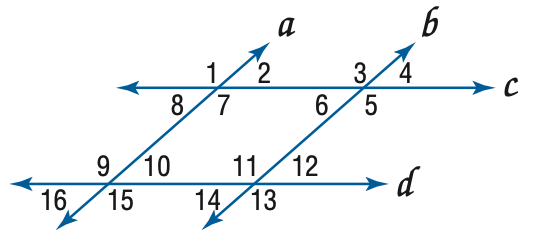Question: In the figure, a \parallel b, c \parallel d, and m \angle 4 = 57. Find the measure of \angle 8.
Choices:
A. 57
B. 113
C. 123
D. 133
Answer with the letter. Answer: A 